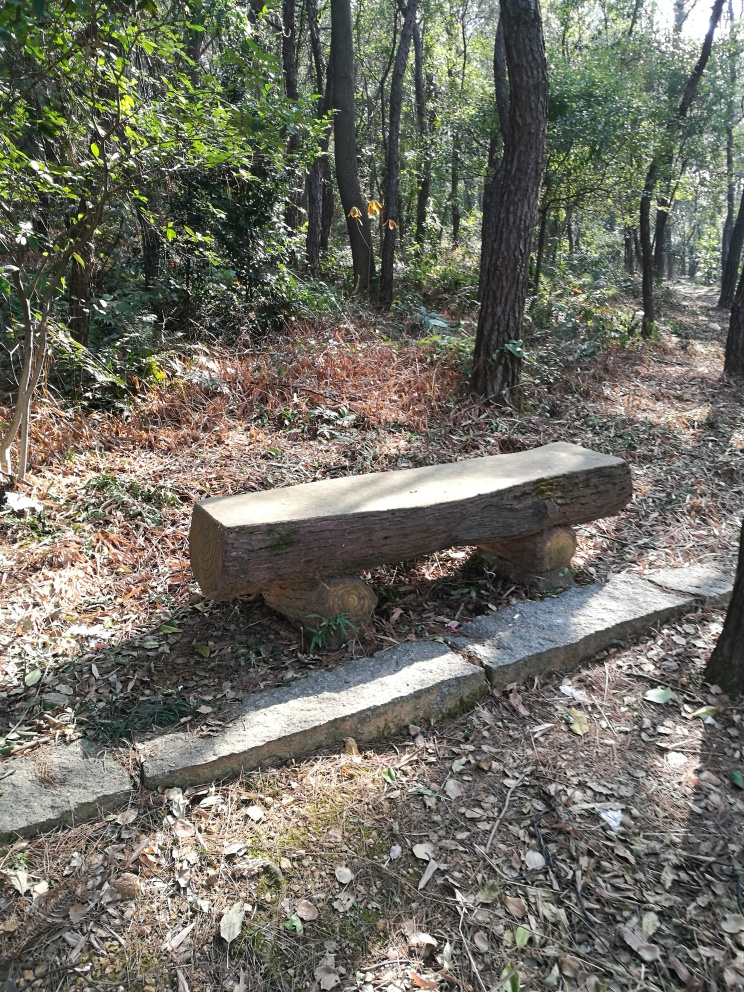What time of day does this image seem to have been taken? Given the angle and intensity of the sunlight filtering through the trees, it suggests the image was taken in the morning when the sun is at a lower position, casting long and soft shadows. 